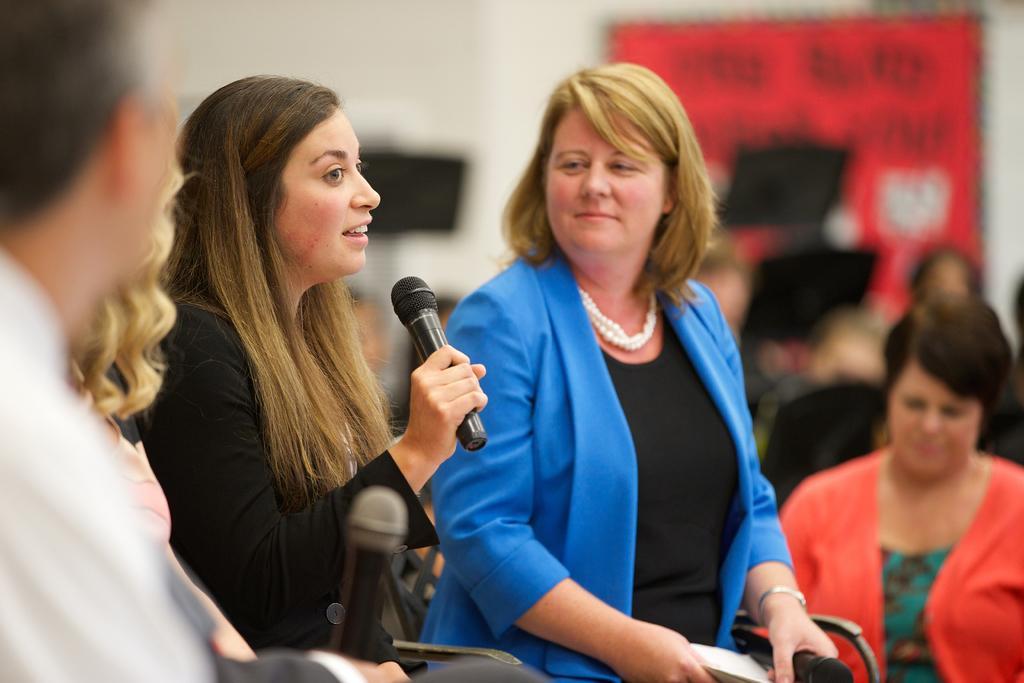Please provide a concise description of this image. This picture is of inside. In the center there is a woman wearing black color dress, holding a microphone and seems to be talking, beside her there is another woman sitting and smiling. On the left corner we can see there are two persons sitting on the chairs. In the background we can see group of people, a banner and a wall. 